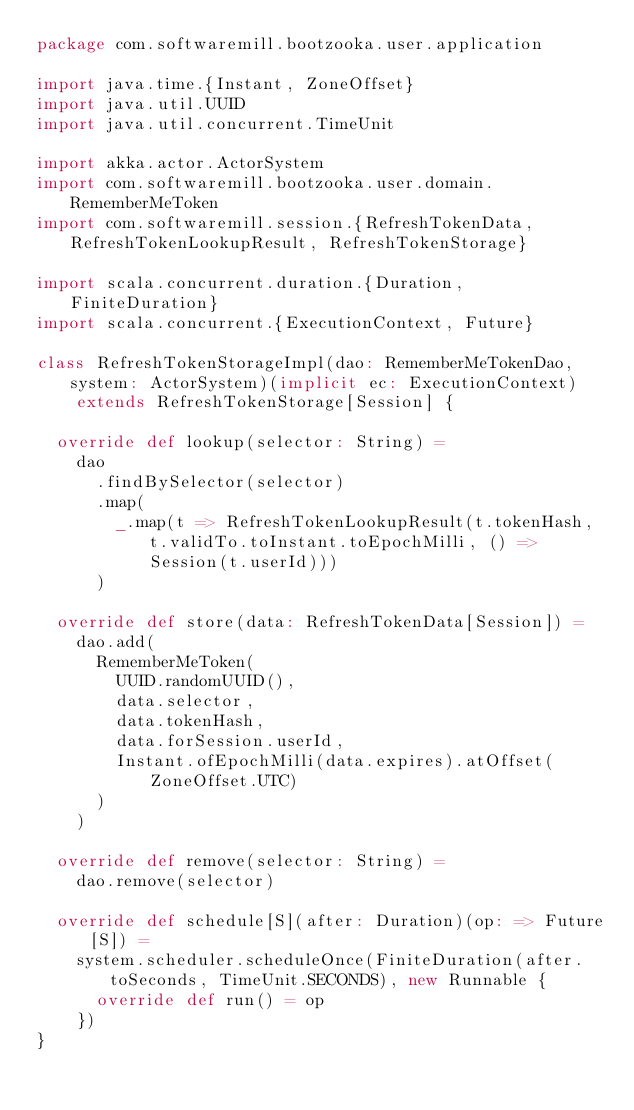Convert code to text. <code><loc_0><loc_0><loc_500><loc_500><_Scala_>package com.softwaremill.bootzooka.user.application

import java.time.{Instant, ZoneOffset}
import java.util.UUID
import java.util.concurrent.TimeUnit

import akka.actor.ActorSystem
import com.softwaremill.bootzooka.user.domain.RememberMeToken
import com.softwaremill.session.{RefreshTokenData, RefreshTokenLookupResult, RefreshTokenStorage}

import scala.concurrent.duration.{Duration, FiniteDuration}
import scala.concurrent.{ExecutionContext, Future}

class RefreshTokenStorageImpl(dao: RememberMeTokenDao, system: ActorSystem)(implicit ec: ExecutionContext)
    extends RefreshTokenStorage[Session] {

  override def lookup(selector: String) =
    dao
      .findBySelector(selector)
      .map(
        _.map(t => RefreshTokenLookupResult(t.tokenHash, t.validTo.toInstant.toEpochMilli, () => Session(t.userId)))
      )

  override def store(data: RefreshTokenData[Session]) =
    dao.add(
      RememberMeToken(
        UUID.randomUUID(),
        data.selector,
        data.tokenHash,
        data.forSession.userId,
        Instant.ofEpochMilli(data.expires).atOffset(ZoneOffset.UTC)
      )
    )

  override def remove(selector: String) =
    dao.remove(selector)

  override def schedule[S](after: Duration)(op: => Future[S]) =
    system.scheduler.scheduleOnce(FiniteDuration(after.toSeconds, TimeUnit.SECONDS), new Runnable {
      override def run() = op
    })
}
</code> 